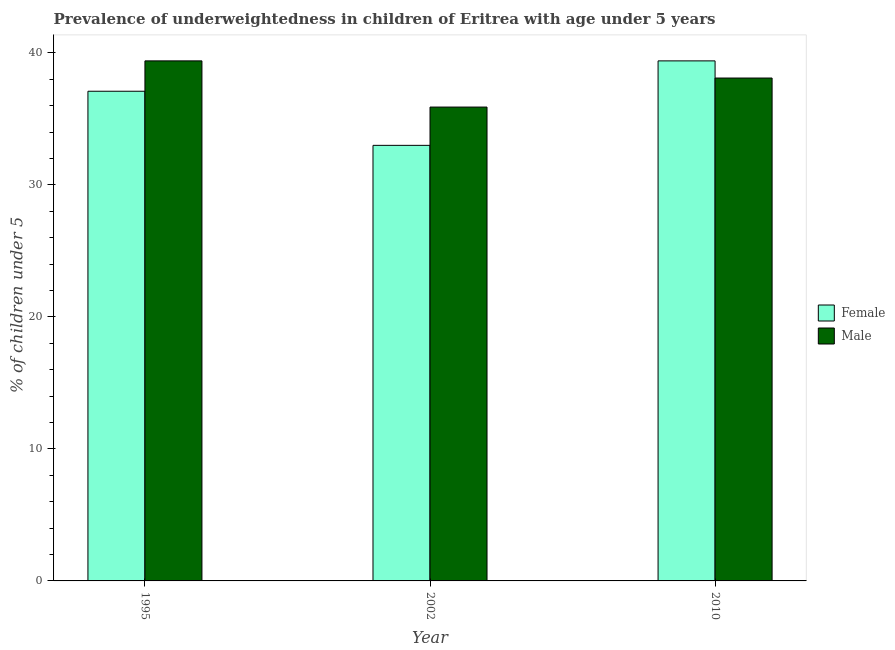How many different coloured bars are there?
Ensure brevity in your answer.  2. How many groups of bars are there?
Provide a short and direct response. 3. Are the number of bars per tick equal to the number of legend labels?
Offer a very short reply. Yes. How many bars are there on the 3rd tick from the left?
Offer a terse response. 2. In how many cases, is the number of bars for a given year not equal to the number of legend labels?
Offer a very short reply. 0. What is the percentage of underweighted female children in 2002?
Make the answer very short. 33. Across all years, what is the maximum percentage of underweighted male children?
Provide a succinct answer. 39.4. Across all years, what is the minimum percentage of underweighted male children?
Ensure brevity in your answer.  35.9. What is the total percentage of underweighted male children in the graph?
Ensure brevity in your answer.  113.4. What is the difference between the percentage of underweighted male children in 2002 and that in 2010?
Your answer should be compact. -2.2. What is the difference between the percentage of underweighted female children in 1995 and the percentage of underweighted male children in 2002?
Provide a succinct answer. 4.1. What is the average percentage of underweighted male children per year?
Give a very brief answer. 37.8. In how many years, is the percentage of underweighted female children greater than 12 %?
Your answer should be very brief. 3. What is the ratio of the percentage of underweighted female children in 2002 to that in 2010?
Keep it short and to the point. 0.84. Is the difference between the percentage of underweighted male children in 1995 and 2010 greater than the difference between the percentage of underweighted female children in 1995 and 2010?
Your answer should be very brief. No. What is the difference between the highest and the second highest percentage of underweighted male children?
Your response must be concise. 1.3. What is the difference between the highest and the lowest percentage of underweighted female children?
Offer a terse response. 6.4. Are the values on the major ticks of Y-axis written in scientific E-notation?
Provide a succinct answer. No. Does the graph contain any zero values?
Give a very brief answer. No. Does the graph contain grids?
Make the answer very short. No. How are the legend labels stacked?
Your response must be concise. Vertical. What is the title of the graph?
Offer a terse response. Prevalence of underweightedness in children of Eritrea with age under 5 years. What is the label or title of the X-axis?
Your answer should be compact. Year. What is the label or title of the Y-axis?
Provide a succinct answer.  % of children under 5. What is the  % of children under 5 of Female in 1995?
Ensure brevity in your answer.  37.1. What is the  % of children under 5 in Male in 1995?
Give a very brief answer. 39.4. What is the  % of children under 5 of Male in 2002?
Provide a short and direct response. 35.9. What is the  % of children under 5 of Female in 2010?
Ensure brevity in your answer.  39.4. What is the  % of children under 5 in Male in 2010?
Your answer should be compact. 38.1. Across all years, what is the maximum  % of children under 5 of Female?
Your answer should be very brief. 39.4. Across all years, what is the maximum  % of children under 5 of Male?
Offer a very short reply. 39.4. Across all years, what is the minimum  % of children under 5 in Male?
Provide a succinct answer. 35.9. What is the total  % of children under 5 of Female in the graph?
Offer a very short reply. 109.5. What is the total  % of children under 5 of Male in the graph?
Provide a succinct answer. 113.4. What is the difference between the  % of children under 5 of Female in 1995 and that in 2002?
Ensure brevity in your answer.  4.1. What is the difference between the  % of children under 5 of Male in 1995 and that in 2010?
Give a very brief answer. 1.3. What is the difference between the  % of children under 5 in Female in 1995 and the  % of children under 5 in Male in 2002?
Provide a short and direct response. 1.2. What is the difference between the  % of children under 5 of Female in 2002 and the  % of children under 5 of Male in 2010?
Provide a short and direct response. -5.1. What is the average  % of children under 5 in Female per year?
Provide a succinct answer. 36.5. What is the average  % of children under 5 of Male per year?
Give a very brief answer. 37.8. In the year 2002, what is the difference between the  % of children under 5 of Female and  % of children under 5 of Male?
Your answer should be compact. -2.9. What is the ratio of the  % of children under 5 in Female in 1995 to that in 2002?
Your answer should be very brief. 1.12. What is the ratio of the  % of children under 5 in Male in 1995 to that in 2002?
Provide a short and direct response. 1.1. What is the ratio of the  % of children under 5 in Female in 1995 to that in 2010?
Ensure brevity in your answer.  0.94. What is the ratio of the  % of children under 5 in Male in 1995 to that in 2010?
Your answer should be compact. 1.03. What is the ratio of the  % of children under 5 in Female in 2002 to that in 2010?
Provide a succinct answer. 0.84. What is the ratio of the  % of children under 5 in Male in 2002 to that in 2010?
Your answer should be very brief. 0.94. What is the difference between the highest and the lowest  % of children under 5 in Male?
Offer a terse response. 3.5. 